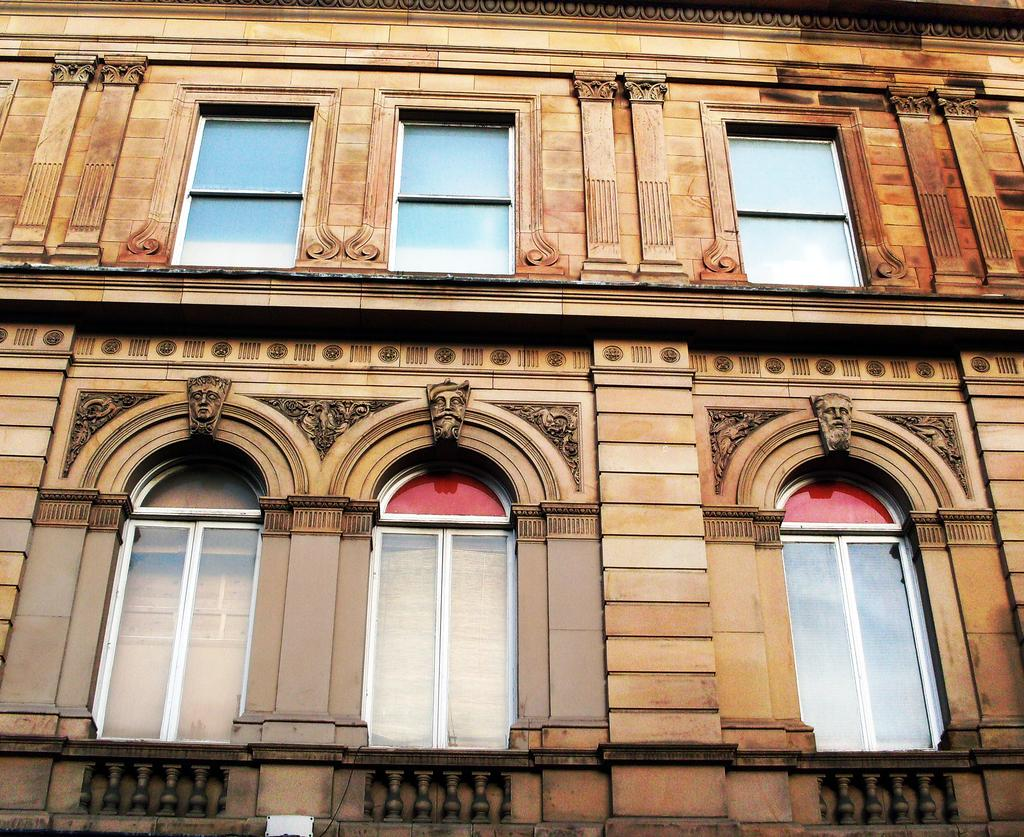What is the main structure visible in the image? There is a building in the image. What feature can be seen on the building? The building has windows. Are there any decorative elements on the windows? Yes, there are statues of persons' faces at the top of the windows. Can you see any dogs playing with cabbage in the image? There are no dogs or cabbage present in the image. 